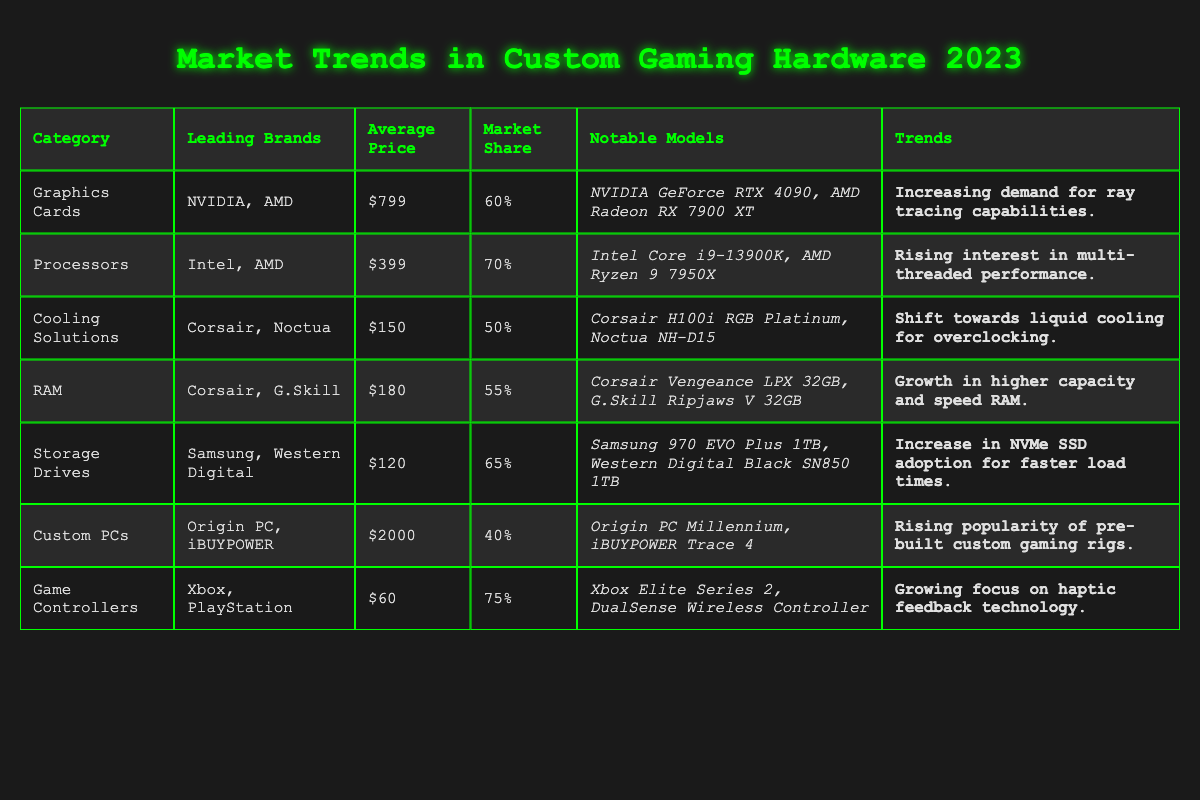What is the leading brand for Graphics Cards? The table indicates that the leading brands for Graphics Cards are NVIDIA and AMD.
Answer: NVIDIA and AMD What is the average price of Processors? The table lists the average price of Processors as $399.
Answer: $399 Which category has the highest market share? The table shows that Game Controllers have the highest market share at 75%.
Answer: Game Controllers What are the notable models for RAM? According to the table, the notable models for RAM are Corsair Vengeance LPX 32GB and G.Skill Ripjaws V 32GB.
Answer: Corsair Vengeance LPX 32GB, G.Skill Ripjaws V 32GB What is the market share of Cooling Solutions? The market share for Cooling Solutions is provided in the table as 50%.
Answer: 50% Is the average price for Custom PCs higher than the average price for Graphics Cards? The average price of Custom PCs is $2000 and for Graphics Cards, it is $799. Since $2000 is greater than $799, the answer is yes.
Answer: Yes What is the combined market share of Graphics Cards and Processors? The market share for Graphics Cards is 60% and for Processors is 70%. Adding these together gives 60% + 70% = 130%.
Answer: 130% Do both categories of Storage Drives and RAM have similar average prices? The average price for Storage Drives is $120 and for RAM is $180. Since $120 is not equal to $180, the answer is no.
Answer: No Which category has the most notable models listed? The table lists notable models for all categories, but the ones for Game Controllers and Processors both have two models mentioned. Comparing all, they tie for the most notable models listed.
Answer: Game Controllers and Processors What trend is associated with Storage Drives? According to the table, the trend associated with Storage Drives is an increase in NVMe SSD adoption for faster load times.
Answer: Increase in NVMe SSD adoption If a gamer wants a high-performance Cooling Solution, which brands should they consider? The table shows that the leading brands for Cooling Solutions are Corsair and Noctua, suggesting they should consider these brands.
Answer: Corsair, Noctua What is the difference between the average price of Game Controllers and RAM? The average price of Game Controllers is $60 and for RAM it is $180. The difference is calculated as $180 - $60 = $120.
Answer: $120 Which category is experiencing rising interest in multi-threaded performance? The table specifies that the category experiencing rising interest in multi-threaded performance is Processors.
Answer: Processors How many categories have a market share of 50% or higher? The categories with market shares of 50% or higher are Graphics Cards (60%), Processors (70%), Storage Drives (65%), Game Controllers (75%). This totals four categories that meet the criterion.
Answer: 4 